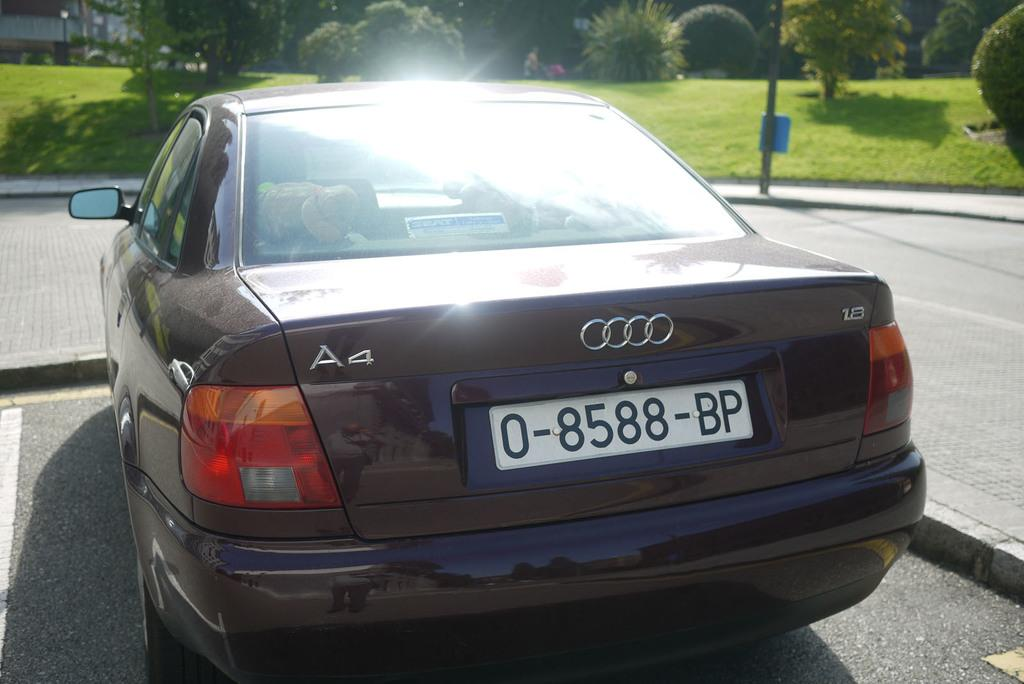<image>
Describe the image concisely. A black car has a license plate numbered 0-8588-BP. 